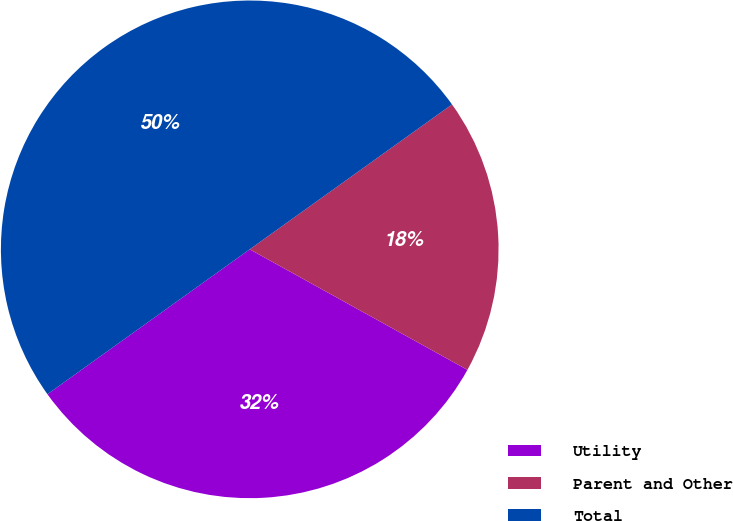<chart> <loc_0><loc_0><loc_500><loc_500><pie_chart><fcel>Utility<fcel>Parent and Other<fcel>Total<nl><fcel>32.06%<fcel>17.94%<fcel>50.0%<nl></chart> 